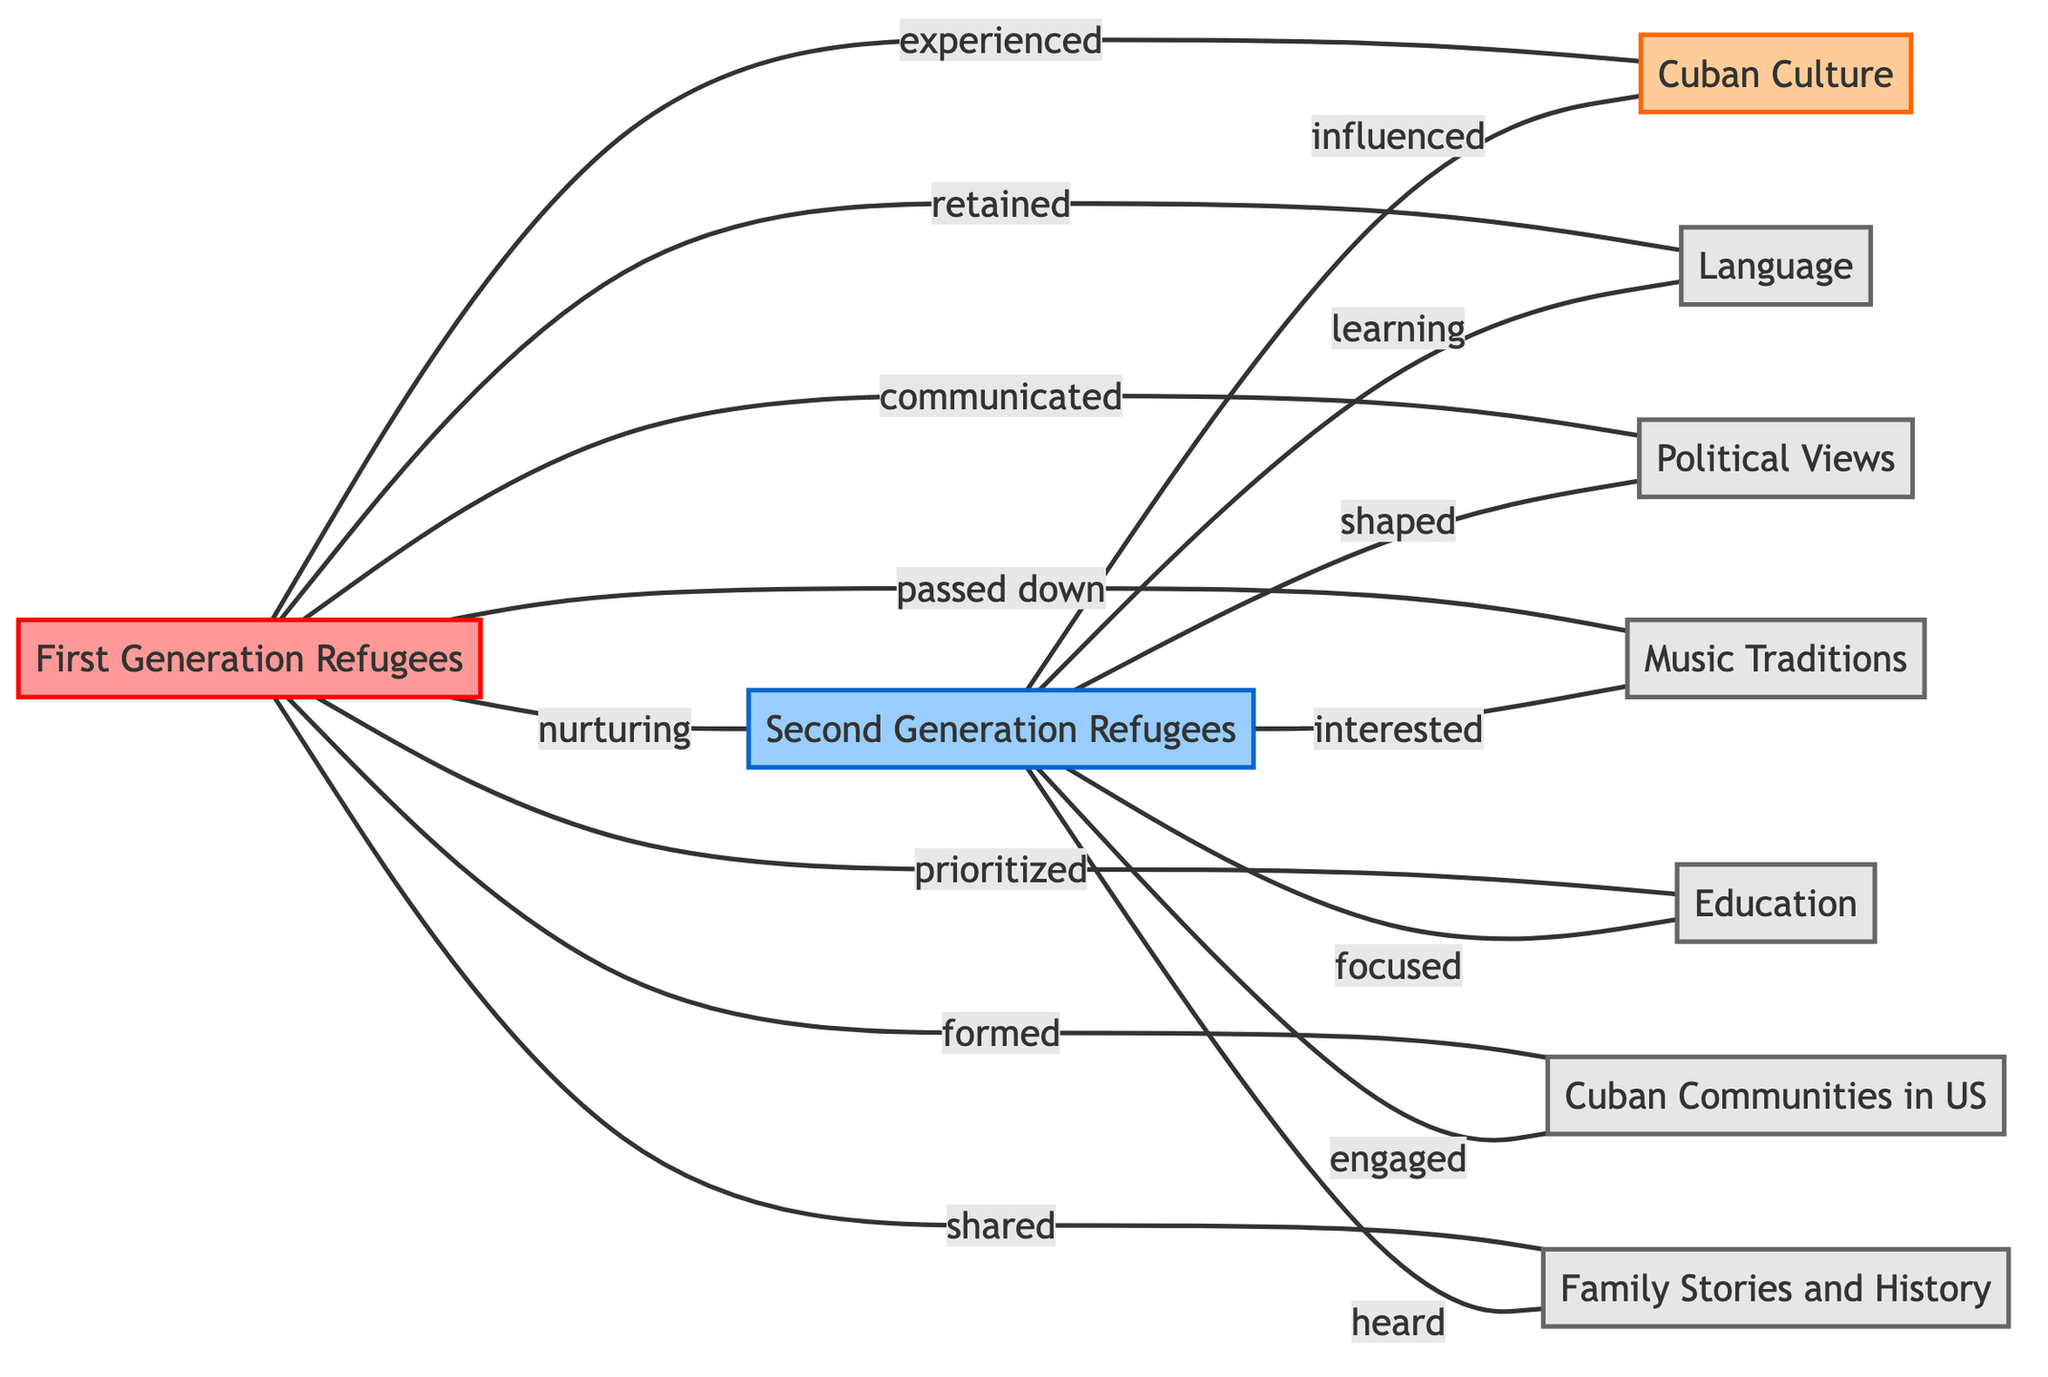What is the total number of nodes in the diagram? The nodes listed in the diagram are: First Generation Refugees, Second Generation Refugees, Cuban Culture, Language, Political Views, Music Traditions, Education, Cuban Communities in US, and Family Stories and History. Counting these gives a total of 9 nodes.
Answer: 9 What is the relationship type between First Generation Refugees and Family Stories and History? The edge between First Generation Refugees and Family Stories and History is labeled 'shared', indicating how first generation refugees communicate stories of their heritage.
Answer: shared Which generation of refugees is described as 'shaped' by Political Views? According to the diagram, Second Generation Refugees are the ones where Political Views are 'shaped'. This indicates that their political perspectives are influenced by prior discussions or teachings.
Answer: Second Generation Refugees How many edges connect First Generation Refugees to Cuban Culture? There is one edge from First Generation Refugees to Cuban Culture that is labeled 'experienced'. Thus, only one edge connects them.
Answer: 1 What are the two languages mentioned in the connections? The connections in the diagram mention 'Language' with edges leading from both First Generation Refugees (retained) and Second Generation Refugees (learning). Therefore, 'Language' is the term referred to here.
Answer: Language How does the connection between Second Generation Refugees and Music Traditions differ from that with First Generation Refugees? The connection with Second Generation Refugees is labeled 'interested', while the connection with First Generation Refugees is labeled 'passed down'. This reflects a difference in engagement levels with the traditions versus their transmission.
Answer: interested; passed down Which node do both generations of refugees engage with in terms of education? Both generations connect to the Education node, with First Generation Refugees prioritizing education and Second Generation Refugees focusing on it, indicating a continuity in the value placed on education across generations.
Answer: Education What is the common connection point for the nodes 'Cuban Communities in US' and the First Generation Refugees? The connection between First Generation Refugees and Cuban Communities in US is described as 'formed'. This suggests that the first generation played a critical role in establishing these communities.
Answer: formed 